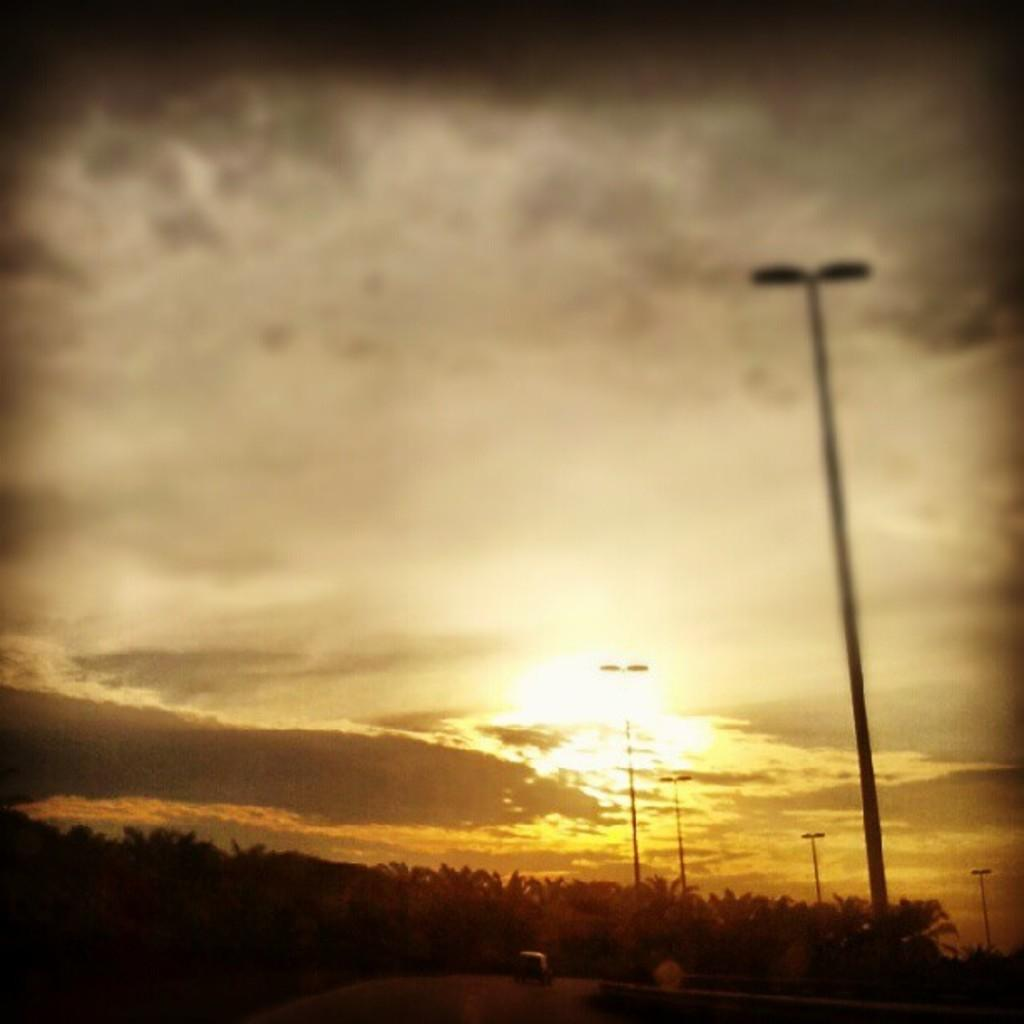What can be seen at the top of the image? The sky is visible in the image. What structures are located on the right side of the image? There are street light poles on the right side of the image. What type of vegetation is present at the bottom of the image? Trees are present at the bottom of the image. Can you see the daughter wearing a veil in the image? There is no daughter or veil present in the image. What type of field can be seen in the image? There is no field present in the image. 